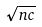<formula> <loc_0><loc_0><loc_500><loc_500>\sqrt { n c }</formula> 